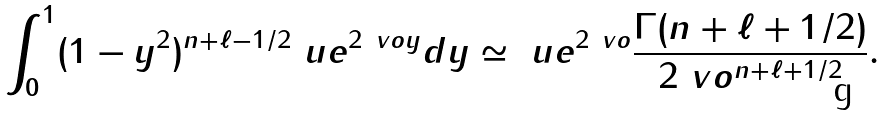Convert formula to latex. <formula><loc_0><loc_0><loc_500><loc_500>\int _ { 0 } ^ { 1 } ( 1 - y ^ { 2 } ) ^ { n + \ell - 1 / 2 } \ u e ^ { 2 \ v o y } d y \simeq \ u e ^ { 2 \ v o } \frac { \Gamma ( n + \ell + 1 / 2 ) } { 2 \ v o ^ { n + \ell + 1 / 2 } } .</formula> 